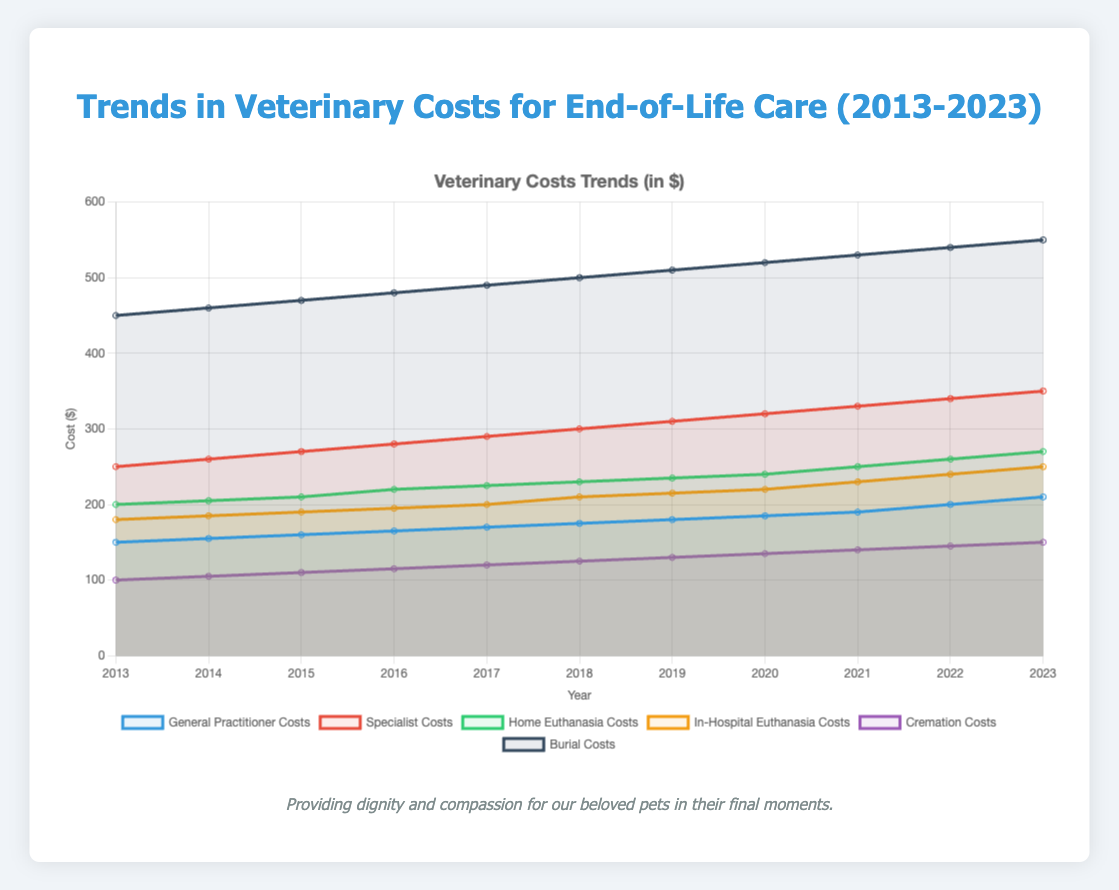Which veterinary care cost increased the most from 2013 to 2023? Look at the figure and find the total increase by subtracting the 2013 value from the 2023 value for each cost category. The largest increase is for Burial Costs, which went from 450 to 550, an increase of 100 dollars.
Answer: Burial Costs What is the average cost of Home Euthanasia from 2013 to 2023? Sum all the yearly costs for Home Euthanasia and divide by the number of years. (200 + 205 + 210 + 220 + 225 + 230 + 235 + 240 + 250 + 260 + 270) / 11 = 235
Answer: 235 Which type of cost is the lowest in 2023? Look at the values for each cost type for 2023 and determine which one is the smallest. Cremation Costs are the lowest at 150 dollars in 2023.
Answer: Cremation Costs How much more did Specialist Costs increase compared to General Practitioner Costs from 2013 to 2023? Subtract the 2013 cost from the 2023 cost for both Specialist and General Practitioner Costs, then find the difference between these increases. Specialist Costs increased by 100 (350-250) and General Practitioner Costs increased by 60 (210-150); 100 - 60 = 40
Answer: 40 dollars By how much did Cremation Costs increase from 2013 to 2023? Subtract the 2013 value from the 2023 value for Cremation Costs. (150 - 100 = 50)
Answer: 50 dollars How does the rate of increase in Home Euthanasia Costs compare to In-Hospital Euthanasia Costs over the last decade? Calculate the total increase from 2013 to 2023 for both Home and In-Hospital Euthanasia Costs, and compare these increases. Home Euthanasia increased by 70 (270-200), while In-Hospital Euthanasia increased by 70 (250-180). Both increased by the same amount, 70 dollars each.
Answer: Equal increase Which cost category has the highest value and which has the lowest value in the year 2023? Look at the values for all cost categories in the year 2023. Burial Costs are the highest at 550 dollars, while Cremation Costs are the lowest at 150 dollars.
Answer: Highest: Burial Costs, Lowest: Cremation Costs If you combine the costs of Home Euthanasia and In-Hospital Euthanasia in 2023, what would be the total cost? Add the values for Home Euthanasia and In-Hospital Euthanasia in 2023. (270 + 250 = 520)
Answer: 520 dollars 